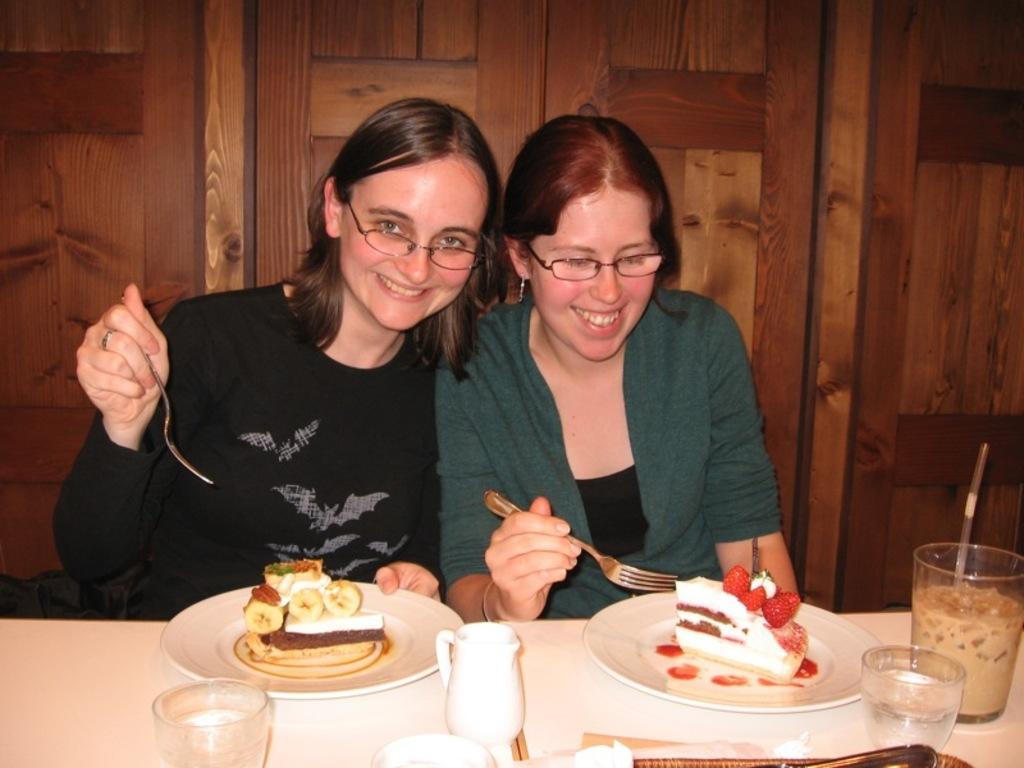Please provide a concise description of this image. In this image, There is a table in white color on that table there are some glasses and there are two plates in that there are some food items and there are two persons sitting and they are holding spoons and in the background there is a brown color wooden doors. 